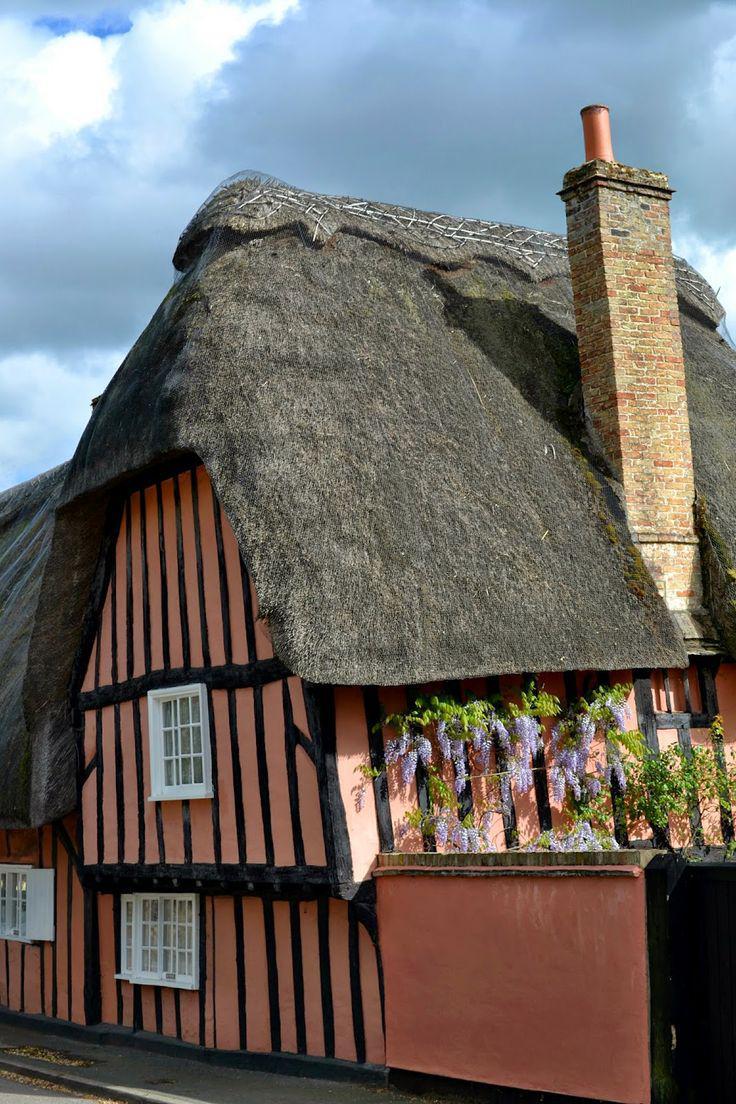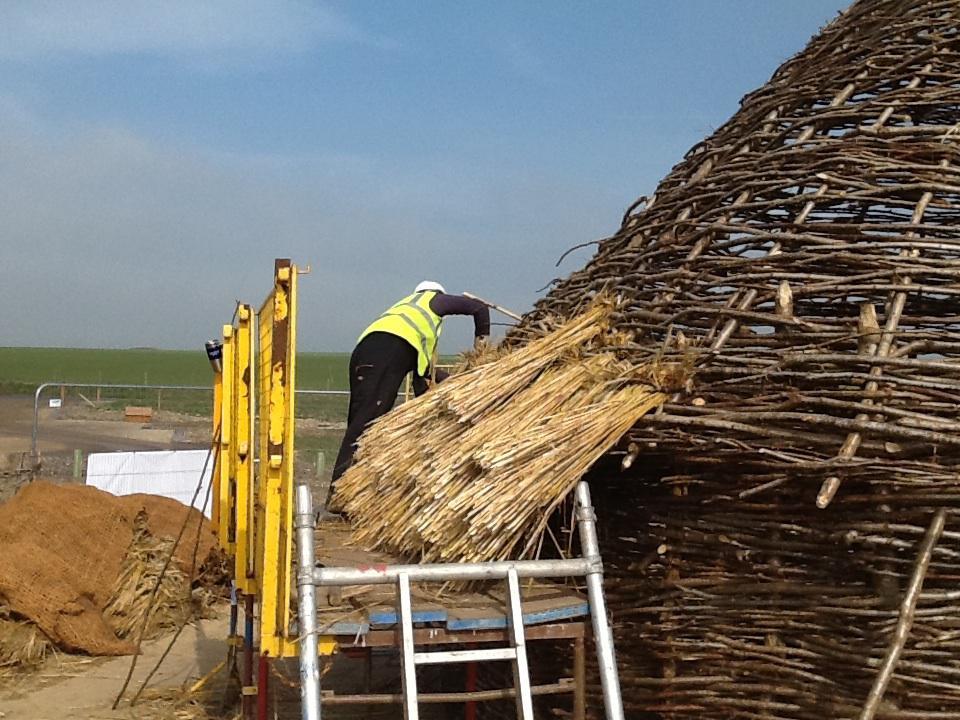The first image is the image on the left, the second image is the image on the right. Analyze the images presented: Is the assertion "The right image shows exactly one man on some type of platform in front of a sloped unfinished roof with at least one bundle of thatch propped on it and no chimney." valid? Answer yes or no. Yes. The first image is the image on the left, the second image is the image on the right. Considering the images on both sides, is "A single man is working on the roof of the house in the image on the right." valid? Answer yes or no. Yes. 